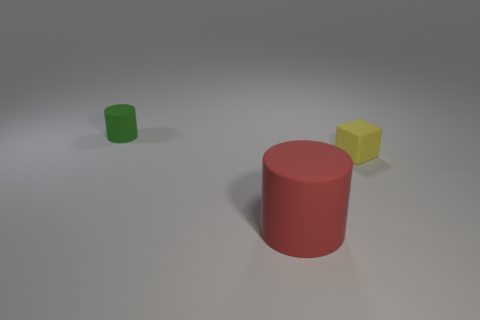Subtract all gray cylinders. Subtract all cyan cubes. How many cylinders are left? 2 Add 3 small yellow matte objects. How many objects exist? 6 Subtract all blocks. How many objects are left? 2 Subtract all large yellow metal spheres. Subtract all green rubber cylinders. How many objects are left? 2 Add 3 cubes. How many cubes are left? 4 Add 3 small yellow rubber cubes. How many small yellow rubber cubes exist? 4 Subtract 0 purple blocks. How many objects are left? 3 